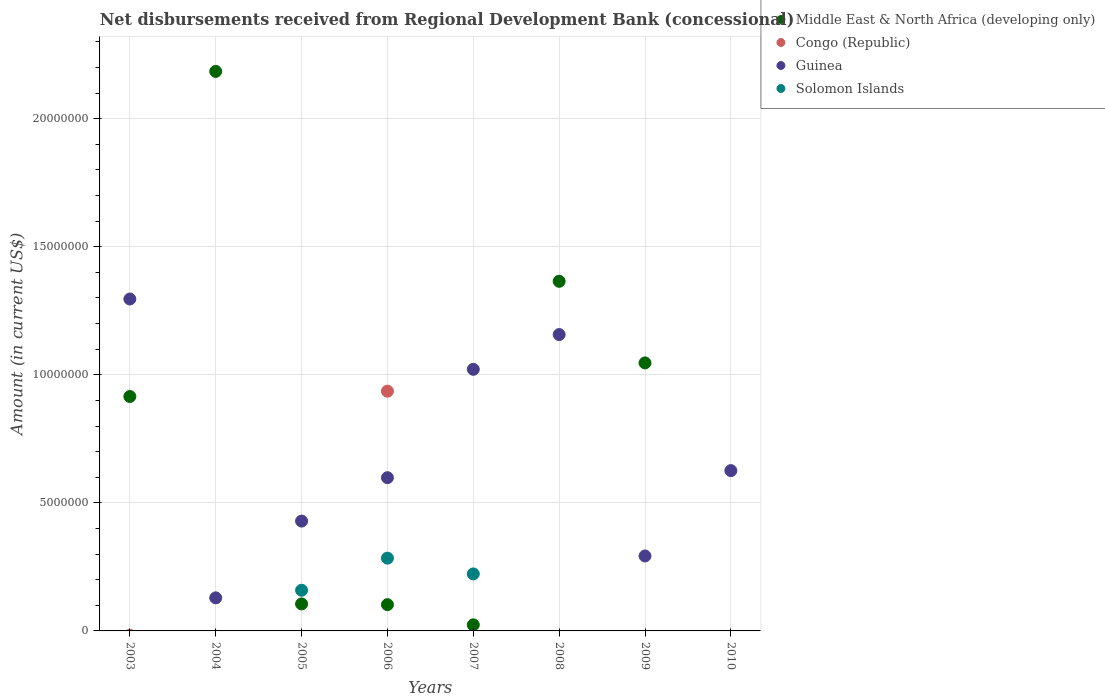Is the number of dotlines equal to the number of legend labels?
Ensure brevity in your answer.  No. What is the amount of disbursements received from Regional Development Bank in Solomon Islands in 2007?
Keep it short and to the point. 2.23e+06. Across all years, what is the maximum amount of disbursements received from Regional Development Bank in Congo (Republic)?
Offer a very short reply. 9.36e+06. Across all years, what is the minimum amount of disbursements received from Regional Development Bank in Guinea?
Provide a short and direct response. 1.29e+06. In which year was the amount of disbursements received from Regional Development Bank in Congo (Republic) maximum?
Your answer should be very brief. 2006. What is the total amount of disbursements received from Regional Development Bank in Guinea in the graph?
Your answer should be compact. 5.55e+07. What is the difference between the amount of disbursements received from Regional Development Bank in Guinea in 2004 and that in 2007?
Your response must be concise. -8.92e+06. What is the difference between the amount of disbursements received from Regional Development Bank in Middle East & North Africa (developing only) in 2005 and the amount of disbursements received from Regional Development Bank in Congo (Republic) in 2007?
Keep it short and to the point. 1.05e+06. What is the average amount of disbursements received from Regional Development Bank in Congo (Republic) per year?
Provide a succinct answer. 1.17e+06. In the year 2007, what is the difference between the amount of disbursements received from Regional Development Bank in Middle East & North Africa (developing only) and amount of disbursements received from Regional Development Bank in Solomon Islands?
Offer a terse response. -1.99e+06. In how many years, is the amount of disbursements received from Regional Development Bank in Middle East & North Africa (developing only) greater than 2000000 US$?
Your answer should be very brief. 4. What is the ratio of the amount of disbursements received from Regional Development Bank in Guinea in 2009 to that in 2010?
Your response must be concise. 0.47. Is the amount of disbursements received from Regional Development Bank in Guinea in 2006 less than that in 2008?
Provide a succinct answer. Yes. What is the difference between the highest and the second highest amount of disbursements received from Regional Development Bank in Solomon Islands?
Make the answer very short. 6.15e+05. What is the difference between the highest and the lowest amount of disbursements received from Regional Development Bank in Guinea?
Keep it short and to the point. 1.17e+07. In how many years, is the amount of disbursements received from Regional Development Bank in Middle East & North Africa (developing only) greater than the average amount of disbursements received from Regional Development Bank in Middle East & North Africa (developing only) taken over all years?
Provide a succinct answer. 4. What is the difference between two consecutive major ticks on the Y-axis?
Offer a very short reply. 5.00e+06. Are the values on the major ticks of Y-axis written in scientific E-notation?
Keep it short and to the point. No. Does the graph contain grids?
Give a very brief answer. Yes. Where does the legend appear in the graph?
Keep it short and to the point. Top right. What is the title of the graph?
Offer a very short reply. Net disbursements received from Regional Development Bank (concessional). Does "Malaysia" appear as one of the legend labels in the graph?
Your answer should be compact. No. What is the label or title of the X-axis?
Provide a succinct answer. Years. What is the label or title of the Y-axis?
Provide a succinct answer. Amount (in current US$). What is the Amount (in current US$) of Middle East & North Africa (developing only) in 2003?
Provide a short and direct response. 9.15e+06. What is the Amount (in current US$) of Guinea in 2003?
Your response must be concise. 1.30e+07. What is the Amount (in current US$) in Middle East & North Africa (developing only) in 2004?
Provide a succinct answer. 2.18e+07. What is the Amount (in current US$) of Congo (Republic) in 2004?
Offer a terse response. 0. What is the Amount (in current US$) in Guinea in 2004?
Your answer should be very brief. 1.29e+06. What is the Amount (in current US$) in Middle East & North Africa (developing only) in 2005?
Provide a succinct answer. 1.05e+06. What is the Amount (in current US$) in Guinea in 2005?
Provide a short and direct response. 4.29e+06. What is the Amount (in current US$) of Solomon Islands in 2005?
Offer a very short reply. 1.59e+06. What is the Amount (in current US$) of Middle East & North Africa (developing only) in 2006?
Offer a terse response. 1.03e+06. What is the Amount (in current US$) of Congo (Republic) in 2006?
Your response must be concise. 9.36e+06. What is the Amount (in current US$) of Guinea in 2006?
Offer a terse response. 5.98e+06. What is the Amount (in current US$) in Solomon Islands in 2006?
Ensure brevity in your answer.  2.84e+06. What is the Amount (in current US$) of Middle East & North Africa (developing only) in 2007?
Ensure brevity in your answer.  2.37e+05. What is the Amount (in current US$) in Congo (Republic) in 2007?
Your response must be concise. 0. What is the Amount (in current US$) in Guinea in 2007?
Ensure brevity in your answer.  1.02e+07. What is the Amount (in current US$) of Solomon Islands in 2007?
Provide a short and direct response. 2.23e+06. What is the Amount (in current US$) of Middle East & North Africa (developing only) in 2008?
Provide a short and direct response. 1.36e+07. What is the Amount (in current US$) of Guinea in 2008?
Your answer should be very brief. 1.16e+07. What is the Amount (in current US$) of Middle East & North Africa (developing only) in 2009?
Offer a very short reply. 1.05e+07. What is the Amount (in current US$) in Congo (Republic) in 2009?
Provide a short and direct response. 0. What is the Amount (in current US$) in Guinea in 2009?
Make the answer very short. 2.93e+06. What is the Amount (in current US$) in Solomon Islands in 2009?
Keep it short and to the point. 0. What is the Amount (in current US$) in Congo (Republic) in 2010?
Your response must be concise. 0. What is the Amount (in current US$) in Guinea in 2010?
Ensure brevity in your answer.  6.26e+06. Across all years, what is the maximum Amount (in current US$) of Middle East & North Africa (developing only)?
Your answer should be compact. 2.18e+07. Across all years, what is the maximum Amount (in current US$) in Congo (Republic)?
Keep it short and to the point. 9.36e+06. Across all years, what is the maximum Amount (in current US$) in Guinea?
Your answer should be compact. 1.30e+07. Across all years, what is the maximum Amount (in current US$) in Solomon Islands?
Make the answer very short. 2.84e+06. Across all years, what is the minimum Amount (in current US$) in Congo (Republic)?
Make the answer very short. 0. Across all years, what is the minimum Amount (in current US$) in Guinea?
Give a very brief answer. 1.29e+06. What is the total Amount (in current US$) in Middle East & North Africa (developing only) in the graph?
Your response must be concise. 5.74e+07. What is the total Amount (in current US$) of Congo (Republic) in the graph?
Offer a terse response. 9.36e+06. What is the total Amount (in current US$) in Guinea in the graph?
Your answer should be very brief. 5.55e+07. What is the total Amount (in current US$) in Solomon Islands in the graph?
Your response must be concise. 6.66e+06. What is the difference between the Amount (in current US$) in Middle East & North Africa (developing only) in 2003 and that in 2004?
Keep it short and to the point. -1.27e+07. What is the difference between the Amount (in current US$) in Guinea in 2003 and that in 2004?
Your answer should be very brief. 1.17e+07. What is the difference between the Amount (in current US$) of Middle East & North Africa (developing only) in 2003 and that in 2005?
Ensure brevity in your answer.  8.10e+06. What is the difference between the Amount (in current US$) of Guinea in 2003 and that in 2005?
Keep it short and to the point. 8.67e+06. What is the difference between the Amount (in current US$) of Middle East & North Africa (developing only) in 2003 and that in 2006?
Ensure brevity in your answer.  8.13e+06. What is the difference between the Amount (in current US$) of Guinea in 2003 and that in 2006?
Your response must be concise. 6.98e+06. What is the difference between the Amount (in current US$) of Middle East & North Africa (developing only) in 2003 and that in 2007?
Provide a succinct answer. 8.92e+06. What is the difference between the Amount (in current US$) in Guinea in 2003 and that in 2007?
Keep it short and to the point. 2.74e+06. What is the difference between the Amount (in current US$) of Middle East & North Africa (developing only) in 2003 and that in 2008?
Keep it short and to the point. -4.50e+06. What is the difference between the Amount (in current US$) in Guinea in 2003 and that in 2008?
Give a very brief answer. 1.39e+06. What is the difference between the Amount (in current US$) of Middle East & North Africa (developing only) in 2003 and that in 2009?
Keep it short and to the point. -1.31e+06. What is the difference between the Amount (in current US$) in Guinea in 2003 and that in 2009?
Make the answer very short. 1.00e+07. What is the difference between the Amount (in current US$) in Guinea in 2003 and that in 2010?
Offer a terse response. 6.70e+06. What is the difference between the Amount (in current US$) of Middle East & North Africa (developing only) in 2004 and that in 2005?
Make the answer very short. 2.08e+07. What is the difference between the Amount (in current US$) in Guinea in 2004 and that in 2005?
Ensure brevity in your answer.  -3.00e+06. What is the difference between the Amount (in current US$) in Middle East & North Africa (developing only) in 2004 and that in 2006?
Your response must be concise. 2.08e+07. What is the difference between the Amount (in current US$) of Guinea in 2004 and that in 2006?
Provide a short and direct response. -4.69e+06. What is the difference between the Amount (in current US$) of Middle East & North Africa (developing only) in 2004 and that in 2007?
Keep it short and to the point. 2.16e+07. What is the difference between the Amount (in current US$) in Guinea in 2004 and that in 2007?
Offer a very short reply. -8.92e+06. What is the difference between the Amount (in current US$) in Middle East & North Africa (developing only) in 2004 and that in 2008?
Your answer should be very brief. 8.20e+06. What is the difference between the Amount (in current US$) of Guinea in 2004 and that in 2008?
Offer a very short reply. -1.03e+07. What is the difference between the Amount (in current US$) of Middle East & North Africa (developing only) in 2004 and that in 2009?
Keep it short and to the point. 1.14e+07. What is the difference between the Amount (in current US$) in Guinea in 2004 and that in 2009?
Offer a very short reply. -1.64e+06. What is the difference between the Amount (in current US$) in Guinea in 2004 and that in 2010?
Your answer should be very brief. -4.97e+06. What is the difference between the Amount (in current US$) of Middle East & North Africa (developing only) in 2005 and that in 2006?
Provide a short and direct response. 2.80e+04. What is the difference between the Amount (in current US$) in Guinea in 2005 and that in 2006?
Provide a succinct answer. -1.70e+06. What is the difference between the Amount (in current US$) in Solomon Islands in 2005 and that in 2006?
Provide a short and direct response. -1.25e+06. What is the difference between the Amount (in current US$) in Middle East & North Africa (developing only) in 2005 and that in 2007?
Ensure brevity in your answer.  8.17e+05. What is the difference between the Amount (in current US$) in Guinea in 2005 and that in 2007?
Make the answer very short. -5.93e+06. What is the difference between the Amount (in current US$) in Solomon Islands in 2005 and that in 2007?
Ensure brevity in your answer.  -6.38e+05. What is the difference between the Amount (in current US$) in Middle East & North Africa (developing only) in 2005 and that in 2008?
Offer a terse response. -1.26e+07. What is the difference between the Amount (in current US$) in Guinea in 2005 and that in 2008?
Offer a very short reply. -7.28e+06. What is the difference between the Amount (in current US$) in Middle East & North Africa (developing only) in 2005 and that in 2009?
Provide a short and direct response. -9.41e+06. What is the difference between the Amount (in current US$) of Guinea in 2005 and that in 2009?
Offer a very short reply. 1.36e+06. What is the difference between the Amount (in current US$) of Guinea in 2005 and that in 2010?
Ensure brevity in your answer.  -1.97e+06. What is the difference between the Amount (in current US$) in Middle East & North Africa (developing only) in 2006 and that in 2007?
Your answer should be compact. 7.89e+05. What is the difference between the Amount (in current US$) of Guinea in 2006 and that in 2007?
Provide a short and direct response. -4.23e+06. What is the difference between the Amount (in current US$) in Solomon Islands in 2006 and that in 2007?
Offer a very short reply. 6.15e+05. What is the difference between the Amount (in current US$) in Middle East & North Africa (developing only) in 2006 and that in 2008?
Your answer should be very brief. -1.26e+07. What is the difference between the Amount (in current US$) of Guinea in 2006 and that in 2008?
Your answer should be very brief. -5.59e+06. What is the difference between the Amount (in current US$) in Middle East & North Africa (developing only) in 2006 and that in 2009?
Keep it short and to the point. -9.44e+06. What is the difference between the Amount (in current US$) in Guinea in 2006 and that in 2009?
Your answer should be very brief. 3.06e+06. What is the difference between the Amount (in current US$) in Guinea in 2006 and that in 2010?
Provide a succinct answer. -2.76e+05. What is the difference between the Amount (in current US$) in Middle East & North Africa (developing only) in 2007 and that in 2008?
Offer a very short reply. -1.34e+07. What is the difference between the Amount (in current US$) in Guinea in 2007 and that in 2008?
Keep it short and to the point. -1.36e+06. What is the difference between the Amount (in current US$) in Middle East & North Africa (developing only) in 2007 and that in 2009?
Offer a terse response. -1.02e+07. What is the difference between the Amount (in current US$) in Guinea in 2007 and that in 2009?
Make the answer very short. 7.29e+06. What is the difference between the Amount (in current US$) of Guinea in 2007 and that in 2010?
Offer a terse response. 3.96e+06. What is the difference between the Amount (in current US$) of Middle East & North Africa (developing only) in 2008 and that in 2009?
Make the answer very short. 3.19e+06. What is the difference between the Amount (in current US$) of Guinea in 2008 and that in 2009?
Offer a terse response. 8.64e+06. What is the difference between the Amount (in current US$) in Guinea in 2008 and that in 2010?
Your answer should be compact. 5.31e+06. What is the difference between the Amount (in current US$) of Guinea in 2009 and that in 2010?
Provide a succinct answer. -3.33e+06. What is the difference between the Amount (in current US$) in Middle East & North Africa (developing only) in 2003 and the Amount (in current US$) in Guinea in 2004?
Offer a terse response. 7.86e+06. What is the difference between the Amount (in current US$) in Middle East & North Africa (developing only) in 2003 and the Amount (in current US$) in Guinea in 2005?
Your answer should be very brief. 4.86e+06. What is the difference between the Amount (in current US$) of Middle East & North Africa (developing only) in 2003 and the Amount (in current US$) of Solomon Islands in 2005?
Ensure brevity in your answer.  7.56e+06. What is the difference between the Amount (in current US$) of Guinea in 2003 and the Amount (in current US$) of Solomon Islands in 2005?
Your response must be concise. 1.14e+07. What is the difference between the Amount (in current US$) in Middle East & North Africa (developing only) in 2003 and the Amount (in current US$) in Congo (Republic) in 2006?
Offer a terse response. -2.07e+05. What is the difference between the Amount (in current US$) of Middle East & North Africa (developing only) in 2003 and the Amount (in current US$) of Guinea in 2006?
Keep it short and to the point. 3.17e+06. What is the difference between the Amount (in current US$) in Middle East & North Africa (developing only) in 2003 and the Amount (in current US$) in Solomon Islands in 2006?
Provide a succinct answer. 6.31e+06. What is the difference between the Amount (in current US$) in Guinea in 2003 and the Amount (in current US$) in Solomon Islands in 2006?
Make the answer very short. 1.01e+07. What is the difference between the Amount (in current US$) of Middle East & North Africa (developing only) in 2003 and the Amount (in current US$) of Guinea in 2007?
Provide a short and direct response. -1.06e+06. What is the difference between the Amount (in current US$) in Middle East & North Africa (developing only) in 2003 and the Amount (in current US$) in Solomon Islands in 2007?
Your answer should be very brief. 6.93e+06. What is the difference between the Amount (in current US$) in Guinea in 2003 and the Amount (in current US$) in Solomon Islands in 2007?
Provide a succinct answer. 1.07e+07. What is the difference between the Amount (in current US$) in Middle East & North Africa (developing only) in 2003 and the Amount (in current US$) in Guinea in 2008?
Provide a short and direct response. -2.42e+06. What is the difference between the Amount (in current US$) of Middle East & North Africa (developing only) in 2003 and the Amount (in current US$) of Guinea in 2009?
Give a very brief answer. 6.23e+06. What is the difference between the Amount (in current US$) of Middle East & North Africa (developing only) in 2003 and the Amount (in current US$) of Guinea in 2010?
Offer a terse response. 2.89e+06. What is the difference between the Amount (in current US$) in Middle East & North Africa (developing only) in 2004 and the Amount (in current US$) in Guinea in 2005?
Offer a terse response. 1.76e+07. What is the difference between the Amount (in current US$) of Middle East & North Africa (developing only) in 2004 and the Amount (in current US$) of Solomon Islands in 2005?
Your answer should be very brief. 2.03e+07. What is the difference between the Amount (in current US$) of Guinea in 2004 and the Amount (in current US$) of Solomon Islands in 2005?
Give a very brief answer. -2.97e+05. What is the difference between the Amount (in current US$) of Middle East & North Africa (developing only) in 2004 and the Amount (in current US$) of Congo (Republic) in 2006?
Your answer should be compact. 1.25e+07. What is the difference between the Amount (in current US$) in Middle East & North Africa (developing only) in 2004 and the Amount (in current US$) in Guinea in 2006?
Give a very brief answer. 1.59e+07. What is the difference between the Amount (in current US$) of Middle East & North Africa (developing only) in 2004 and the Amount (in current US$) of Solomon Islands in 2006?
Give a very brief answer. 1.90e+07. What is the difference between the Amount (in current US$) of Guinea in 2004 and the Amount (in current US$) of Solomon Islands in 2006?
Provide a succinct answer. -1.55e+06. What is the difference between the Amount (in current US$) of Middle East & North Africa (developing only) in 2004 and the Amount (in current US$) of Guinea in 2007?
Provide a succinct answer. 1.16e+07. What is the difference between the Amount (in current US$) of Middle East & North Africa (developing only) in 2004 and the Amount (in current US$) of Solomon Islands in 2007?
Give a very brief answer. 1.96e+07. What is the difference between the Amount (in current US$) of Guinea in 2004 and the Amount (in current US$) of Solomon Islands in 2007?
Offer a very short reply. -9.35e+05. What is the difference between the Amount (in current US$) in Middle East & North Africa (developing only) in 2004 and the Amount (in current US$) in Guinea in 2008?
Offer a very short reply. 1.03e+07. What is the difference between the Amount (in current US$) of Middle East & North Africa (developing only) in 2004 and the Amount (in current US$) of Guinea in 2009?
Your response must be concise. 1.89e+07. What is the difference between the Amount (in current US$) in Middle East & North Africa (developing only) in 2004 and the Amount (in current US$) in Guinea in 2010?
Provide a succinct answer. 1.56e+07. What is the difference between the Amount (in current US$) of Middle East & North Africa (developing only) in 2005 and the Amount (in current US$) of Congo (Republic) in 2006?
Provide a short and direct response. -8.31e+06. What is the difference between the Amount (in current US$) in Middle East & North Africa (developing only) in 2005 and the Amount (in current US$) in Guinea in 2006?
Provide a short and direct response. -4.93e+06. What is the difference between the Amount (in current US$) of Middle East & North Africa (developing only) in 2005 and the Amount (in current US$) of Solomon Islands in 2006?
Provide a succinct answer. -1.79e+06. What is the difference between the Amount (in current US$) of Guinea in 2005 and the Amount (in current US$) of Solomon Islands in 2006?
Keep it short and to the point. 1.45e+06. What is the difference between the Amount (in current US$) of Middle East & North Africa (developing only) in 2005 and the Amount (in current US$) of Guinea in 2007?
Provide a succinct answer. -9.16e+06. What is the difference between the Amount (in current US$) in Middle East & North Africa (developing only) in 2005 and the Amount (in current US$) in Solomon Islands in 2007?
Your answer should be very brief. -1.17e+06. What is the difference between the Amount (in current US$) in Guinea in 2005 and the Amount (in current US$) in Solomon Islands in 2007?
Your response must be concise. 2.06e+06. What is the difference between the Amount (in current US$) of Middle East & North Africa (developing only) in 2005 and the Amount (in current US$) of Guinea in 2008?
Offer a very short reply. -1.05e+07. What is the difference between the Amount (in current US$) of Middle East & North Africa (developing only) in 2005 and the Amount (in current US$) of Guinea in 2009?
Your response must be concise. -1.87e+06. What is the difference between the Amount (in current US$) in Middle East & North Africa (developing only) in 2005 and the Amount (in current US$) in Guinea in 2010?
Ensure brevity in your answer.  -5.20e+06. What is the difference between the Amount (in current US$) in Middle East & North Africa (developing only) in 2006 and the Amount (in current US$) in Guinea in 2007?
Give a very brief answer. -9.19e+06. What is the difference between the Amount (in current US$) in Middle East & North Africa (developing only) in 2006 and the Amount (in current US$) in Solomon Islands in 2007?
Your answer should be very brief. -1.20e+06. What is the difference between the Amount (in current US$) in Congo (Republic) in 2006 and the Amount (in current US$) in Guinea in 2007?
Provide a succinct answer. -8.54e+05. What is the difference between the Amount (in current US$) in Congo (Republic) in 2006 and the Amount (in current US$) in Solomon Islands in 2007?
Provide a short and direct response. 7.13e+06. What is the difference between the Amount (in current US$) in Guinea in 2006 and the Amount (in current US$) in Solomon Islands in 2007?
Provide a succinct answer. 3.76e+06. What is the difference between the Amount (in current US$) of Middle East & North Africa (developing only) in 2006 and the Amount (in current US$) of Guinea in 2008?
Give a very brief answer. -1.05e+07. What is the difference between the Amount (in current US$) of Congo (Republic) in 2006 and the Amount (in current US$) of Guinea in 2008?
Provide a short and direct response. -2.21e+06. What is the difference between the Amount (in current US$) in Middle East & North Africa (developing only) in 2006 and the Amount (in current US$) in Guinea in 2009?
Keep it short and to the point. -1.90e+06. What is the difference between the Amount (in current US$) of Congo (Republic) in 2006 and the Amount (in current US$) of Guinea in 2009?
Your answer should be very brief. 6.43e+06. What is the difference between the Amount (in current US$) in Middle East & North Africa (developing only) in 2006 and the Amount (in current US$) in Guinea in 2010?
Keep it short and to the point. -5.23e+06. What is the difference between the Amount (in current US$) in Congo (Republic) in 2006 and the Amount (in current US$) in Guinea in 2010?
Your answer should be very brief. 3.10e+06. What is the difference between the Amount (in current US$) of Middle East & North Africa (developing only) in 2007 and the Amount (in current US$) of Guinea in 2008?
Make the answer very short. -1.13e+07. What is the difference between the Amount (in current US$) of Middle East & North Africa (developing only) in 2007 and the Amount (in current US$) of Guinea in 2009?
Offer a very short reply. -2.69e+06. What is the difference between the Amount (in current US$) of Middle East & North Africa (developing only) in 2007 and the Amount (in current US$) of Guinea in 2010?
Provide a succinct answer. -6.02e+06. What is the difference between the Amount (in current US$) in Middle East & North Africa (developing only) in 2008 and the Amount (in current US$) in Guinea in 2009?
Ensure brevity in your answer.  1.07e+07. What is the difference between the Amount (in current US$) in Middle East & North Africa (developing only) in 2008 and the Amount (in current US$) in Guinea in 2010?
Offer a terse response. 7.39e+06. What is the difference between the Amount (in current US$) of Middle East & North Africa (developing only) in 2009 and the Amount (in current US$) of Guinea in 2010?
Provide a succinct answer. 4.20e+06. What is the average Amount (in current US$) of Middle East & North Africa (developing only) per year?
Provide a succinct answer. 7.18e+06. What is the average Amount (in current US$) of Congo (Republic) per year?
Provide a short and direct response. 1.17e+06. What is the average Amount (in current US$) in Guinea per year?
Give a very brief answer. 6.94e+06. What is the average Amount (in current US$) of Solomon Islands per year?
Ensure brevity in your answer.  8.32e+05. In the year 2003, what is the difference between the Amount (in current US$) in Middle East & North Africa (developing only) and Amount (in current US$) in Guinea?
Keep it short and to the point. -3.81e+06. In the year 2004, what is the difference between the Amount (in current US$) in Middle East & North Africa (developing only) and Amount (in current US$) in Guinea?
Make the answer very short. 2.06e+07. In the year 2005, what is the difference between the Amount (in current US$) in Middle East & North Africa (developing only) and Amount (in current US$) in Guinea?
Keep it short and to the point. -3.23e+06. In the year 2005, what is the difference between the Amount (in current US$) in Middle East & North Africa (developing only) and Amount (in current US$) in Solomon Islands?
Your response must be concise. -5.34e+05. In the year 2005, what is the difference between the Amount (in current US$) in Guinea and Amount (in current US$) in Solomon Islands?
Keep it short and to the point. 2.70e+06. In the year 2006, what is the difference between the Amount (in current US$) in Middle East & North Africa (developing only) and Amount (in current US$) in Congo (Republic)?
Offer a very short reply. -8.33e+06. In the year 2006, what is the difference between the Amount (in current US$) of Middle East & North Africa (developing only) and Amount (in current US$) of Guinea?
Your answer should be compact. -4.96e+06. In the year 2006, what is the difference between the Amount (in current US$) in Middle East & North Africa (developing only) and Amount (in current US$) in Solomon Islands?
Offer a very short reply. -1.82e+06. In the year 2006, what is the difference between the Amount (in current US$) of Congo (Republic) and Amount (in current US$) of Guinea?
Your answer should be very brief. 3.38e+06. In the year 2006, what is the difference between the Amount (in current US$) in Congo (Republic) and Amount (in current US$) in Solomon Islands?
Offer a very short reply. 6.52e+06. In the year 2006, what is the difference between the Amount (in current US$) of Guinea and Amount (in current US$) of Solomon Islands?
Give a very brief answer. 3.14e+06. In the year 2007, what is the difference between the Amount (in current US$) in Middle East & North Africa (developing only) and Amount (in current US$) in Guinea?
Offer a very short reply. -9.98e+06. In the year 2007, what is the difference between the Amount (in current US$) of Middle East & North Africa (developing only) and Amount (in current US$) of Solomon Islands?
Provide a short and direct response. -1.99e+06. In the year 2007, what is the difference between the Amount (in current US$) in Guinea and Amount (in current US$) in Solomon Islands?
Offer a terse response. 7.99e+06. In the year 2008, what is the difference between the Amount (in current US$) of Middle East & North Africa (developing only) and Amount (in current US$) of Guinea?
Provide a succinct answer. 2.08e+06. In the year 2009, what is the difference between the Amount (in current US$) in Middle East & North Africa (developing only) and Amount (in current US$) in Guinea?
Offer a terse response. 7.54e+06. What is the ratio of the Amount (in current US$) of Middle East & North Africa (developing only) in 2003 to that in 2004?
Your answer should be very brief. 0.42. What is the ratio of the Amount (in current US$) in Guinea in 2003 to that in 2004?
Offer a terse response. 10.04. What is the ratio of the Amount (in current US$) in Middle East & North Africa (developing only) in 2003 to that in 2005?
Your response must be concise. 8.68. What is the ratio of the Amount (in current US$) in Guinea in 2003 to that in 2005?
Offer a terse response. 3.02. What is the ratio of the Amount (in current US$) of Middle East & North Africa (developing only) in 2003 to that in 2006?
Your answer should be compact. 8.92. What is the ratio of the Amount (in current US$) of Guinea in 2003 to that in 2006?
Provide a succinct answer. 2.17. What is the ratio of the Amount (in current US$) in Middle East & North Africa (developing only) in 2003 to that in 2007?
Offer a very short reply. 38.62. What is the ratio of the Amount (in current US$) in Guinea in 2003 to that in 2007?
Offer a very short reply. 1.27. What is the ratio of the Amount (in current US$) of Middle East & North Africa (developing only) in 2003 to that in 2008?
Give a very brief answer. 0.67. What is the ratio of the Amount (in current US$) in Guinea in 2003 to that in 2008?
Ensure brevity in your answer.  1.12. What is the ratio of the Amount (in current US$) of Middle East & North Africa (developing only) in 2003 to that in 2009?
Ensure brevity in your answer.  0.87. What is the ratio of the Amount (in current US$) in Guinea in 2003 to that in 2009?
Keep it short and to the point. 4.43. What is the ratio of the Amount (in current US$) in Guinea in 2003 to that in 2010?
Offer a very short reply. 2.07. What is the ratio of the Amount (in current US$) in Middle East & North Africa (developing only) in 2004 to that in 2005?
Your answer should be compact. 20.73. What is the ratio of the Amount (in current US$) in Guinea in 2004 to that in 2005?
Provide a succinct answer. 0.3. What is the ratio of the Amount (in current US$) in Middle East & North Africa (developing only) in 2004 to that in 2006?
Your response must be concise. 21.29. What is the ratio of the Amount (in current US$) in Guinea in 2004 to that in 2006?
Your response must be concise. 0.22. What is the ratio of the Amount (in current US$) in Middle East & North Africa (developing only) in 2004 to that in 2007?
Your answer should be very brief. 92.17. What is the ratio of the Amount (in current US$) in Guinea in 2004 to that in 2007?
Keep it short and to the point. 0.13. What is the ratio of the Amount (in current US$) in Middle East & North Africa (developing only) in 2004 to that in 2008?
Your answer should be compact. 1.6. What is the ratio of the Amount (in current US$) in Guinea in 2004 to that in 2008?
Your response must be concise. 0.11. What is the ratio of the Amount (in current US$) in Middle East & North Africa (developing only) in 2004 to that in 2009?
Your answer should be very brief. 2.09. What is the ratio of the Amount (in current US$) in Guinea in 2004 to that in 2009?
Provide a short and direct response. 0.44. What is the ratio of the Amount (in current US$) in Guinea in 2004 to that in 2010?
Provide a succinct answer. 0.21. What is the ratio of the Amount (in current US$) in Middle East & North Africa (developing only) in 2005 to that in 2006?
Your answer should be compact. 1.03. What is the ratio of the Amount (in current US$) in Guinea in 2005 to that in 2006?
Offer a terse response. 0.72. What is the ratio of the Amount (in current US$) in Solomon Islands in 2005 to that in 2006?
Your answer should be very brief. 0.56. What is the ratio of the Amount (in current US$) in Middle East & North Africa (developing only) in 2005 to that in 2007?
Provide a short and direct response. 4.45. What is the ratio of the Amount (in current US$) of Guinea in 2005 to that in 2007?
Your answer should be compact. 0.42. What is the ratio of the Amount (in current US$) in Solomon Islands in 2005 to that in 2007?
Ensure brevity in your answer.  0.71. What is the ratio of the Amount (in current US$) in Middle East & North Africa (developing only) in 2005 to that in 2008?
Your response must be concise. 0.08. What is the ratio of the Amount (in current US$) of Guinea in 2005 to that in 2008?
Provide a succinct answer. 0.37. What is the ratio of the Amount (in current US$) in Middle East & North Africa (developing only) in 2005 to that in 2009?
Provide a succinct answer. 0.1. What is the ratio of the Amount (in current US$) of Guinea in 2005 to that in 2009?
Provide a short and direct response. 1.47. What is the ratio of the Amount (in current US$) of Guinea in 2005 to that in 2010?
Your answer should be very brief. 0.69. What is the ratio of the Amount (in current US$) in Middle East & North Africa (developing only) in 2006 to that in 2007?
Provide a succinct answer. 4.33. What is the ratio of the Amount (in current US$) of Guinea in 2006 to that in 2007?
Offer a very short reply. 0.59. What is the ratio of the Amount (in current US$) of Solomon Islands in 2006 to that in 2007?
Provide a short and direct response. 1.28. What is the ratio of the Amount (in current US$) of Middle East & North Africa (developing only) in 2006 to that in 2008?
Your answer should be very brief. 0.08. What is the ratio of the Amount (in current US$) in Guinea in 2006 to that in 2008?
Give a very brief answer. 0.52. What is the ratio of the Amount (in current US$) in Middle East & North Africa (developing only) in 2006 to that in 2009?
Ensure brevity in your answer.  0.1. What is the ratio of the Amount (in current US$) of Guinea in 2006 to that in 2009?
Ensure brevity in your answer.  2.04. What is the ratio of the Amount (in current US$) in Guinea in 2006 to that in 2010?
Keep it short and to the point. 0.96. What is the ratio of the Amount (in current US$) of Middle East & North Africa (developing only) in 2007 to that in 2008?
Offer a very short reply. 0.02. What is the ratio of the Amount (in current US$) in Guinea in 2007 to that in 2008?
Give a very brief answer. 0.88. What is the ratio of the Amount (in current US$) of Middle East & North Africa (developing only) in 2007 to that in 2009?
Make the answer very short. 0.02. What is the ratio of the Amount (in current US$) of Guinea in 2007 to that in 2009?
Your answer should be compact. 3.49. What is the ratio of the Amount (in current US$) in Guinea in 2007 to that in 2010?
Keep it short and to the point. 1.63. What is the ratio of the Amount (in current US$) of Middle East & North Africa (developing only) in 2008 to that in 2009?
Ensure brevity in your answer.  1.3. What is the ratio of the Amount (in current US$) of Guinea in 2008 to that in 2009?
Your answer should be compact. 3.95. What is the ratio of the Amount (in current US$) of Guinea in 2008 to that in 2010?
Your response must be concise. 1.85. What is the ratio of the Amount (in current US$) in Guinea in 2009 to that in 2010?
Offer a very short reply. 0.47. What is the difference between the highest and the second highest Amount (in current US$) of Middle East & North Africa (developing only)?
Your response must be concise. 8.20e+06. What is the difference between the highest and the second highest Amount (in current US$) in Guinea?
Your answer should be very brief. 1.39e+06. What is the difference between the highest and the second highest Amount (in current US$) in Solomon Islands?
Your answer should be very brief. 6.15e+05. What is the difference between the highest and the lowest Amount (in current US$) of Middle East & North Africa (developing only)?
Make the answer very short. 2.18e+07. What is the difference between the highest and the lowest Amount (in current US$) in Congo (Republic)?
Your response must be concise. 9.36e+06. What is the difference between the highest and the lowest Amount (in current US$) in Guinea?
Your answer should be very brief. 1.17e+07. What is the difference between the highest and the lowest Amount (in current US$) in Solomon Islands?
Give a very brief answer. 2.84e+06. 